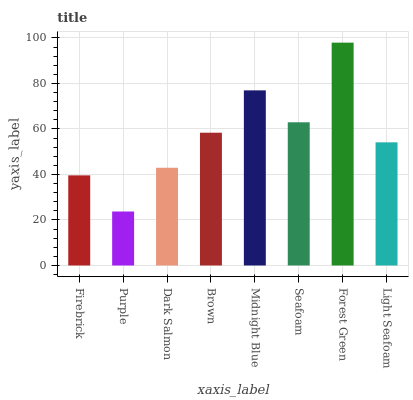Is Dark Salmon the minimum?
Answer yes or no. No. Is Dark Salmon the maximum?
Answer yes or no. No. Is Dark Salmon greater than Purple?
Answer yes or no. Yes. Is Purple less than Dark Salmon?
Answer yes or no. Yes. Is Purple greater than Dark Salmon?
Answer yes or no. No. Is Dark Salmon less than Purple?
Answer yes or no. No. Is Brown the high median?
Answer yes or no. Yes. Is Light Seafoam the low median?
Answer yes or no. Yes. Is Firebrick the high median?
Answer yes or no. No. Is Firebrick the low median?
Answer yes or no. No. 